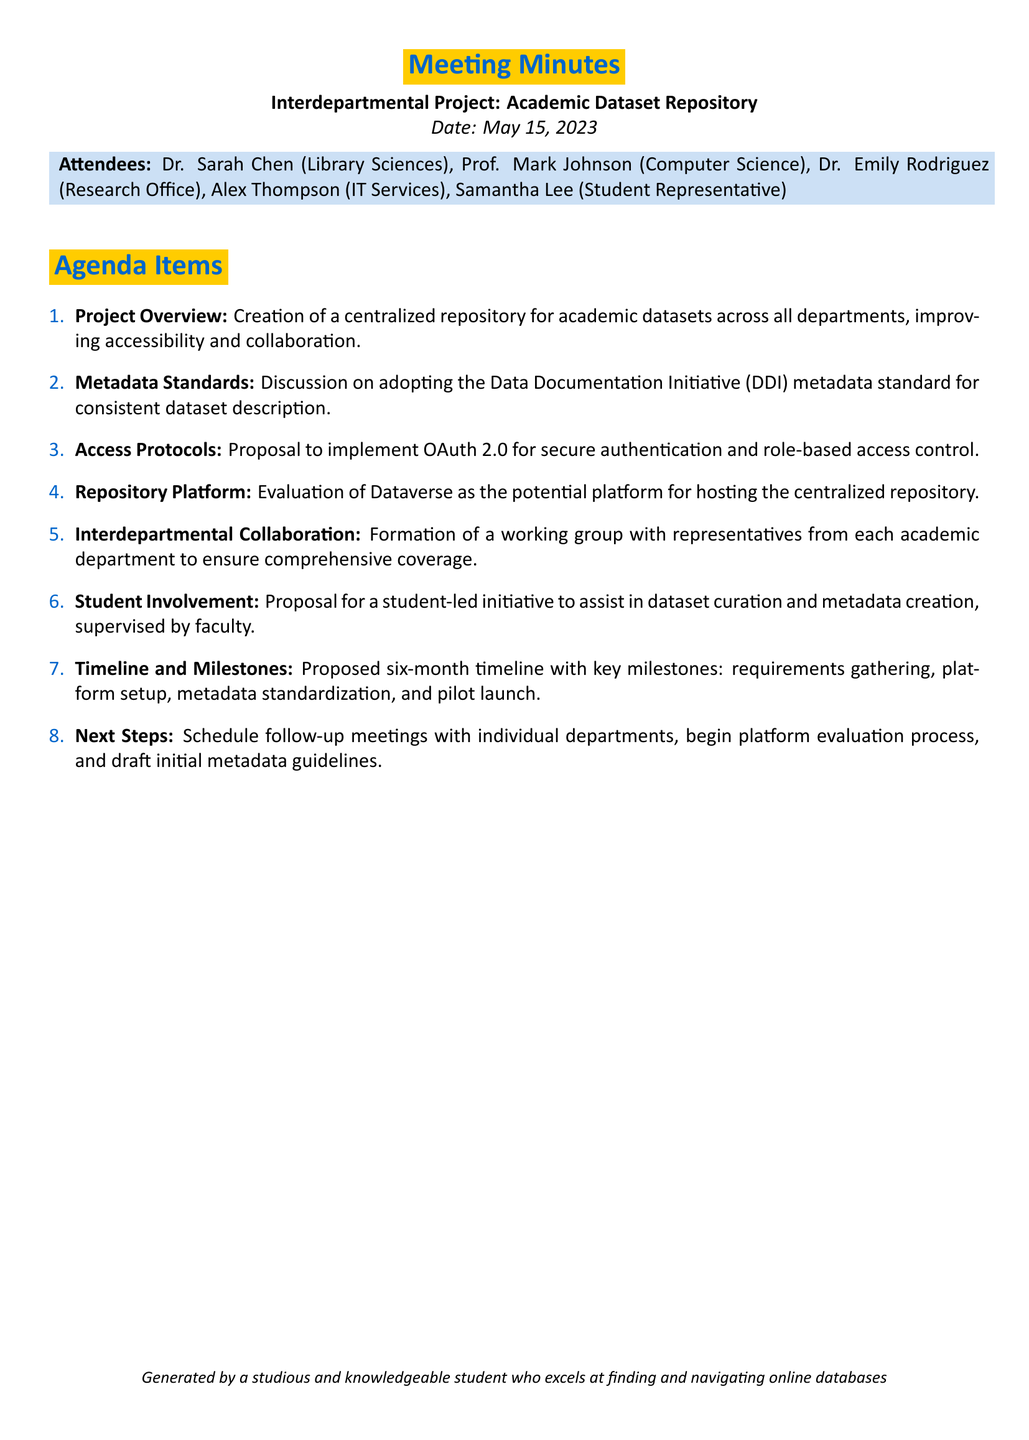What is the date of the meeting? The date of the meeting is specified at the beginning of the minutes.
Answer: May 15, 2023 Who proposed the student-led initiative? The document lists the attendees and discusses proposals, pointing to the context of the student-led initiative.
Answer: Samantha Lee What metadata standard is discussed? The meeting minutes include a discussion on adopting a specific metadata standard.
Answer: Data Documentation Initiative (DDI) How many agenda items are listed? The agenda items are numbered in a list format within the document.
Answer: Eight What is the proposed timeline for the project? The document specifies a timeline mentioned within the agenda items.
Answer: Six months Which platform is evaluated for hosting the repository? The document identifies a specific platform for the centralized repository in one of the agenda items.
Answer: Dataverse What is the main goal of the project? The primary objective is outlined in the project overview section of the minutes.
Answer: Improve accessibility and collaboration What is the next step mentioned in the meeting? The next steps are explicitly mentioned towards the end of the agenda items.
Answer: Schedule follow-up meetings 